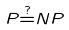Convert formula to latex. <formula><loc_0><loc_0><loc_500><loc_500>P { \overset { ? } { = } } N P</formula> 